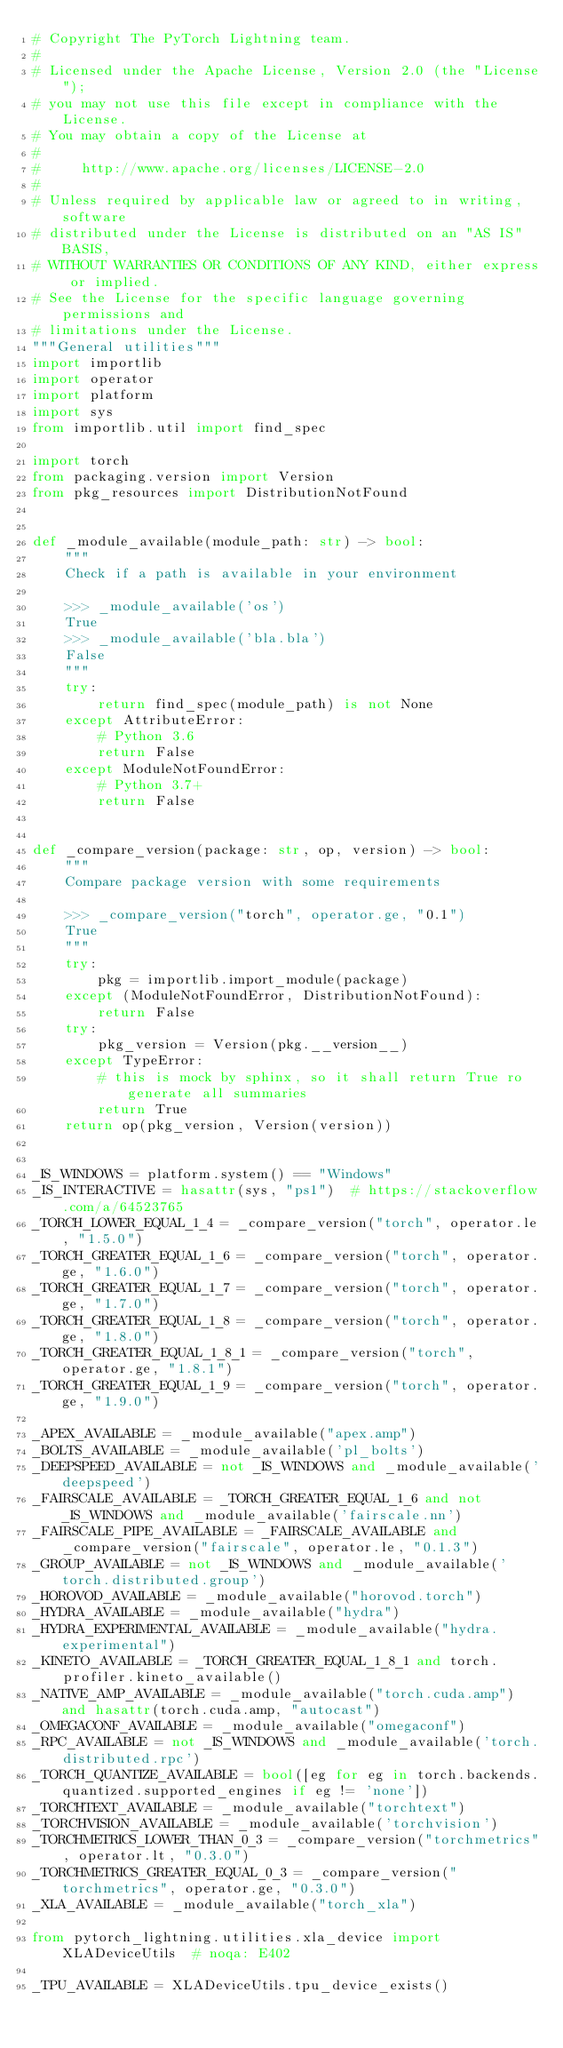<code> <loc_0><loc_0><loc_500><loc_500><_Python_># Copyright The PyTorch Lightning team.
#
# Licensed under the Apache License, Version 2.0 (the "License");
# you may not use this file except in compliance with the License.
# You may obtain a copy of the License at
#
#     http://www.apache.org/licenses/LICENSE-2.0
#
# Unless required by applicable law or agreed to in writing, software
# distributed under the License is distributed on an "AS IS" BASIS,
# WITHOUT WARRANTIES OR CONDITIONS OF ANY KIND, either express or implied.
# See the License for the specific language governing permissions and
# limitations under the License.
"""General utilities"""
import importlib
import operator
import platform
import sys
from importlib.util import find_spec

import torch
from packaging.version import Version
from pkg_resources import DistributionNotFound


def _module_available(module_path: str) -> bool:
    """
    Check if a path is available in your environment

    >>> _module_available('os')
    True
    >>> _module_available('bla.bla')
    False
    """
    try:
        return find_spec(module_path) is not None
    except AttributeError:
        # Python 3.6
        return False
    except ModuleNotFoundError:
        # Python 3.7+
        return False


def _compare_version(package: str, op, version) -> bool:
    """
    Compare package version with some requirements

    >>> _compare_version("torch", operator.ge, "0.1")
    True
    """
    try:
        pkg = importlib.import_module(package)
    except (ModuleNotFoundError, DistributionNotFound):
        return False
    try:
        pkg_version = Version(pkg.__version__)
    except TypeError:
        # this is mock by sphinx, so it shall return True ro generate all summaries
        return True
    return op(pkg_version, Version(version))


_IS_WINDOWS = platform.system() == "Windows"
_IS_INTERACTIVE = hasattr(sys, "ps1")  # https://stackoverflow.com/a/64523765
_TORCH_LOWER_EQUAL_1_4 = _compare_version("torch", operator.le, "1.5.0")
_TORCH_GREATER_EQUAL_1_6 = _compare_version("torch", operator.ge, "1.6.0")
_TORCH_GREATER_EQUAL_1_7 = _compare_version("torch", operator.ge, "1.7.0")
_TORCH_GREATER_EQUAL_1_8 = _compare_version("torch", operator.ge, "1.8.0")
_TORCH_GREATER_EQUAL_1_8_1 = _compare_version("torch", operator.ge, "1.8.1")
_TORCH_GREATER_EQUAL_1_9 = _compare_version("torch", operator.ge, "1.9.0")

_APEX_AVAILABLE = _module_available("apex.amp")
_BOLTS_AVAILABLE = _module_available('pl_bolts')
_DEEPSPEED_AVAILABLE = not _IS_WINDOWS and _module_available('deepspeed')
_FAIRSCALE_AVAILABLE = _TORCH_GREATER_EQUAL_1_6 and not _IS_WINDOWS and _module_available('fairscale.nn')
_FAIRSCALE_PIPE_AVAILABLE = _FAIRSCALE_AVAILABLE and _compare_version("fairscale", operator.le, "0.1.3")
_GROUP_AVAILABLE = not _IS_WINDOWS and _module_available('torch.distributed.group')
_HOROVOD_AVAILABLE = _module_available("horovod.torch")
_HYDRA_AVAILABLE = _module_available("hydra")
_HYDRA_EXPERIMENTAL_AVAILABLE = _module_available("hydra.experimental")
_KINETO_AVAILABLE = _TORCH_GREATER_EQUAL_1_8_1 and torch.profiler.kineto_available()
_NATIVE_AMP_AVAILABLE = _module_available("torch.cuda.amp") and hasattr(torch.cuda.amp, "autocast")
_OMEGACONF_AVAILABLE = _module_available("omegaconf")
_RPC_AVAILABLE = not _IS_WINDOWS and _module_available('torch.distributed.rpc')
_TORCH_QUANTIZE_AVAILABLE = bool([eg for eg in torch.backends.quantized.supported_engines if eg != 'none'])
_TORCHTEXT_AVAILABLE = _module_available("torchtext")
_TORCHVISION_AVAILABLE = _module_available('torchvision')
_TORCHMETRICS_LOWER_THAN_0_3 = _compare_version("torchmetrics", operator.lt, "0.3.0")
_TORCHMETRICS_GREATER_EQUAL_0_3 = _compare_version("torchmetrics", operator.ge, "0.3.0")
_XLA_AVAILABLE = _module_available("torch_xla")

from pytorch_lightning.utilities.xla_device import XLADeviceUtils  # noqa: E402

_TPU_AVAILABLE = XLADeviceUtils.tpu_device_exists()
</code> 